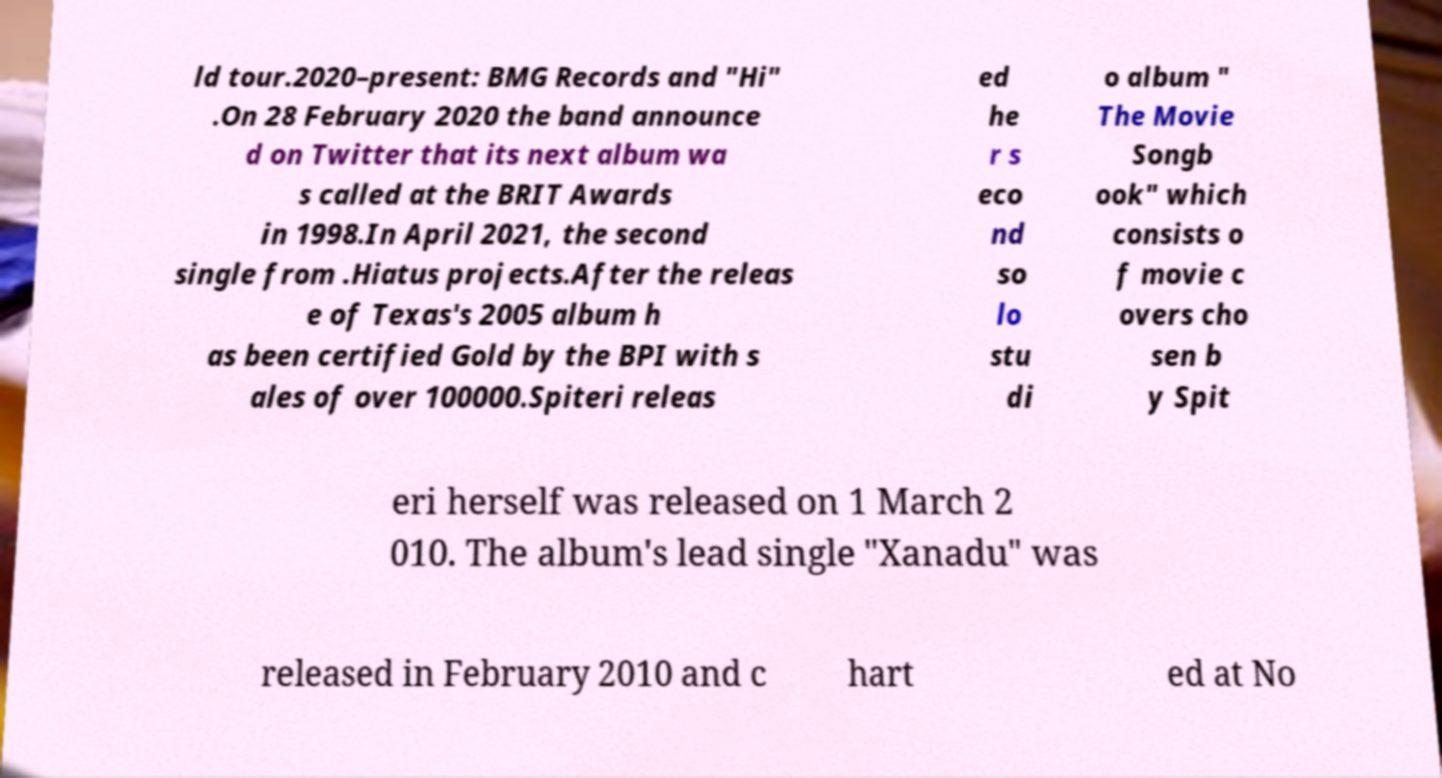Could you assist in decoding the text presented in this image and type it out clearly? ld tour.2020–present: BMG Records and "Hi" .On 28 February 2020 the band announce d on Twitter that its next album wa s called at the BRIT Awards in 1998.In April 2021, the second single from .Hiatus projects.After the releas e of Texas's 2005 album h as been certified Gold by the BPI with s ales of over 100000.Spiteri releas ed he r s eco nd so lo stu di o album " The Movie Songb ook" which consists o f movie c overs cho sen b y Spit eri herself was released on 1 March 2 010. The album's lead single "Xanadu" was released in February 2010 and c hart ed at No 